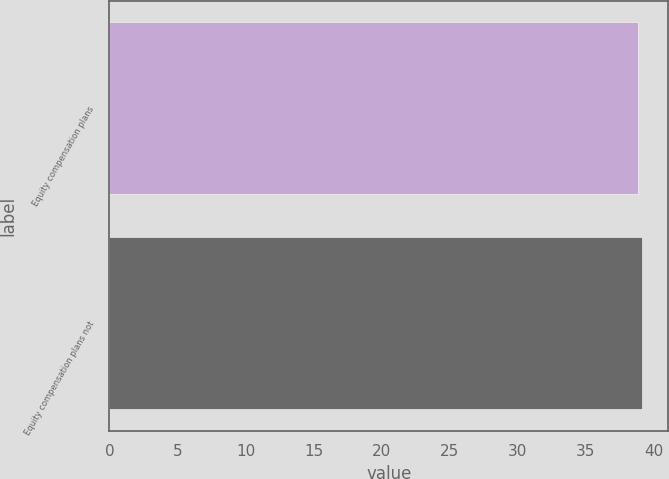Convert chart to OTSL. <chart><loc_0><loc_0><loc_500><loc_500><bar_chart><fcel>Equity compensation plans<fcel>Equity compensation plans not<nl><fcel>38.82<fcel>39.11<nl></chart> 